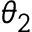<formula> <loc_0><loc_0><loc_500><loc_500>\theta _ { 2 }</formula> 